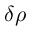<formula> <loc_0><loc_0><loc_500><loc_500>\delta \rho</formula> 